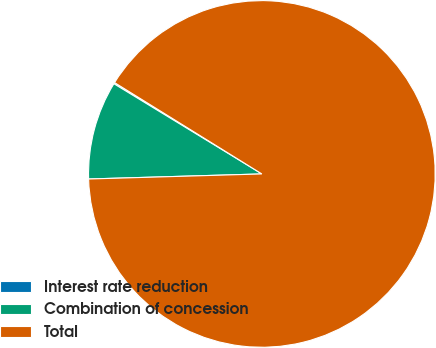Convert chart. <chart><loc_0><loc_0><loc_500><loc_500><pie_chart><fcel>Interest rate reduction<fcel>Combination of concession<fcel>Total<nl><fcel>0.12%<fcel>9.18%<fcel>90.7%<nl></chart> 